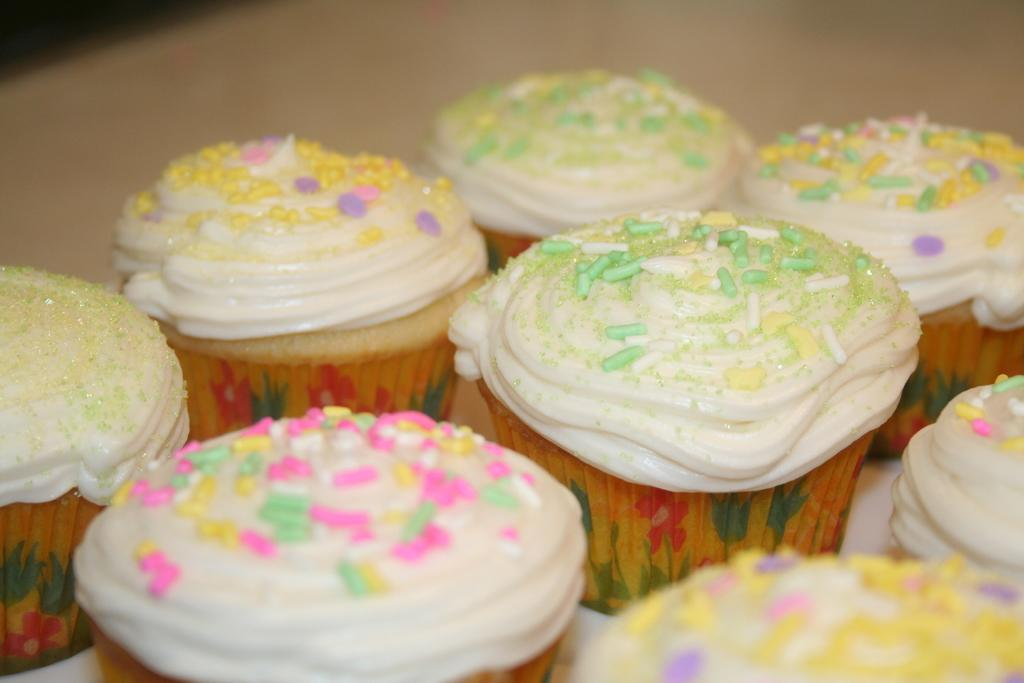What is the color of the surface in the image? The surface in the image is cream-colored. What type of food is on the surface? There are cupcakes on the surface. How many different colors can be seen on the cupcakes? The cupcakes are pink, green, cream, yellow, and brown in color. Where is the hose located in the image? There is no hose present in the image. What type of animals can be seen at the zoo in the image? There is no zoo or animals present in the image. 